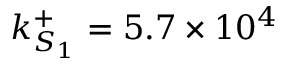<formula> <loc_0><loc_0><loc_500><loc_500>k _ { S _ { 1 } } ^ { + } = 5 . 7 \times 1 0 ^ { 4 }</formula> 